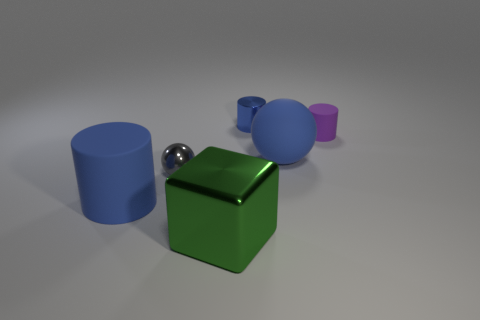Subtract all small cylinders. How many cylinders are left? 1 Add 2 purple rubber objects. How many objects exist? 8 Subtract all red balls. How many blue cylinders are left? 2 Subtract 1 cylinders. How many cylinders are left? 2 Subtract 0 yellow spheres. How many objects are left? 6 Subtract all blocks. How many objects are left? 5 Subtract all brown blocks. Subtract all purple balls. How many blocks are left? 1 Subtract all matte cubes. Subtract all tiny blue metal cylinders. How many objects are left? 5 Add 5 small purple matte cylinders. How many small purple matte cylinders are left? 6 Add 2 blue cylinders. How many blue cylinders exist? 4 